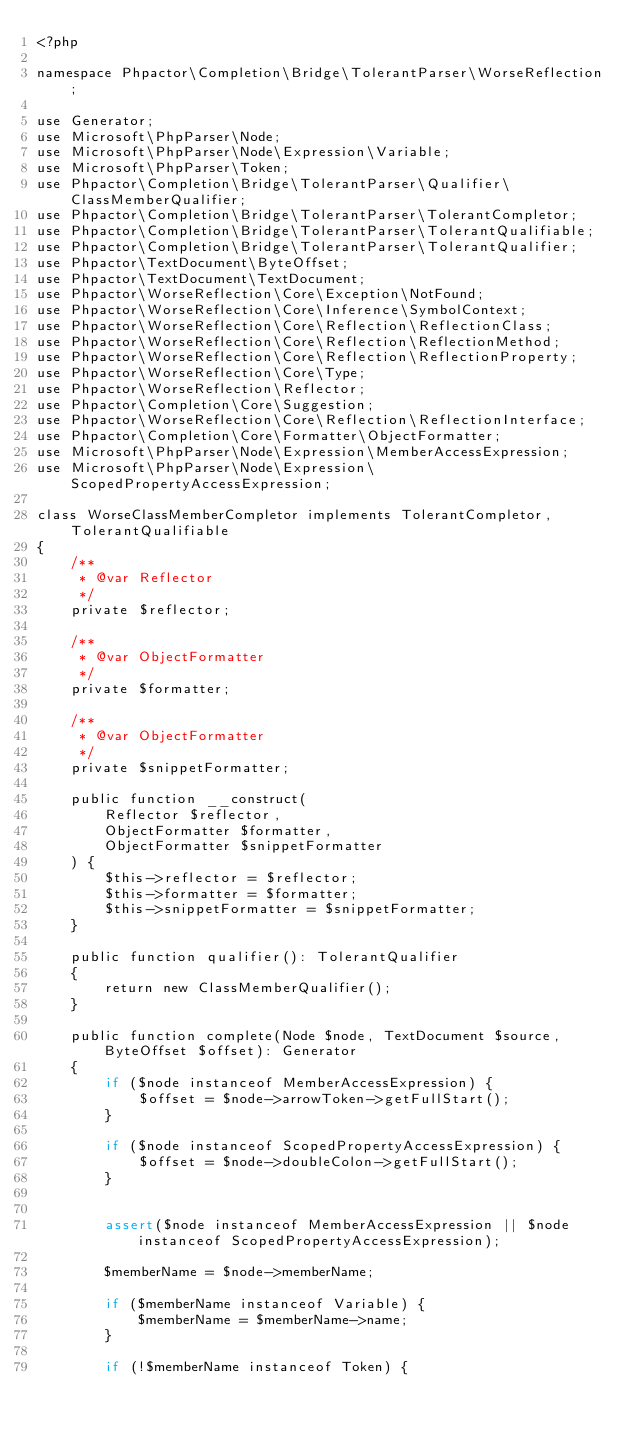<code> <loc_0><loc_0><loc_500><loc_500><_PHP_><?php

namespace Phpactor\Completion\Bridge\TolerantParser\WorseReflection;

use Generator;
use Microsoft\PhpParser\Node;
use Microsoft\PhpParser\Node\Expression\Variable;
use Microsoft\PhpParser\Token;
use Phpactor\Completion\Bridge\TolerantParser\Qualifier\ClassMemberQualifier;
use Phpactor\Completion\Bridge\TolerantParser\TolerantCompletor;
use Phpactor\Completion\Bridge\TolerantParser\TolerantQualifiable;
use Phpactor\Completion\Bridge\TolerantParser\TolerantQualifier;
use Phpactor\TextDocument\ByteOffset;
use Phpactor\TextDocument\TextDocument;
use Phpactor\WorseReflection\Core\Exception\NotFound;
use Phpactor\WorseReflection\Core\Inference\SymbolContext;
use Phpactor\WorseReflection\Core\Reflection\ReflectionClass;
use Phpactor\WorseReflection\Core\Reflection\ReflectionMethod;
use Phpactor\WorseReflection\Core\Reflection\ReflectionProperty;
use Phpactor\WorseReflection\Core\Type;
use Phpactor\WorseReflection\Reflector;
use Phpactor\Completion\Core\Suggestion;
use Phpactor\WorseReflection\Core\Reflection\ReflectionInterface;
use Phpactor\Completion\Core\Formatter\ObjectFormatter;
use Microsoft\PhpParser\Node\Expression\MemberAccessExpression;
use Microsoft\PhpParser\Node\Expression\ScopedPropertyAccessExpression;

class WorseClassMemberCompletor implements TolerantCompletor, TolerantQualifiable
{
    /**
     * @var Reflector
     */
    private $reflector;

    /**
     * @var ObjectFormatter
     */
    private $formatter;

    /**
     * @var ObjectFormatter
     */
    private $snippetFormatter;

    public function __construct(
        Reflector $reflector,
        ObjectFormatter $formatter,
        ObjectFormatter $snippetFormatter
    ) {
        $this->reflector = $reflector;
        $this->formatter = $formatter;
        $this->snippetFormatter = $snippetFormatter;
    }

    public function qualifier(): TolerantQualifier
    {
        return new ClassMemberQualifier();
    }

    public function complete(Node $node, TextDocument $source, ByteOffset $offset): Generator
    {
        if ($node instanceof MemberAccessExpression) {
            $offset = $node->arrowToken->getFullStart();
        }

        if ($node instanceof ScopedPropertyAccessExpression) {
            $offset = $node->doubleColon->getFullStart();
        }


        assert($node instanceof MemberAccessExpression || $node instanceof ScopedPropertyAccessExpression);

        $memberName = $node->memberName;

        if ($memberName instanceof Variable) {
            $memberName = $memberName->name;
        }

        if (!$memberName instanceof Token) {</code> 